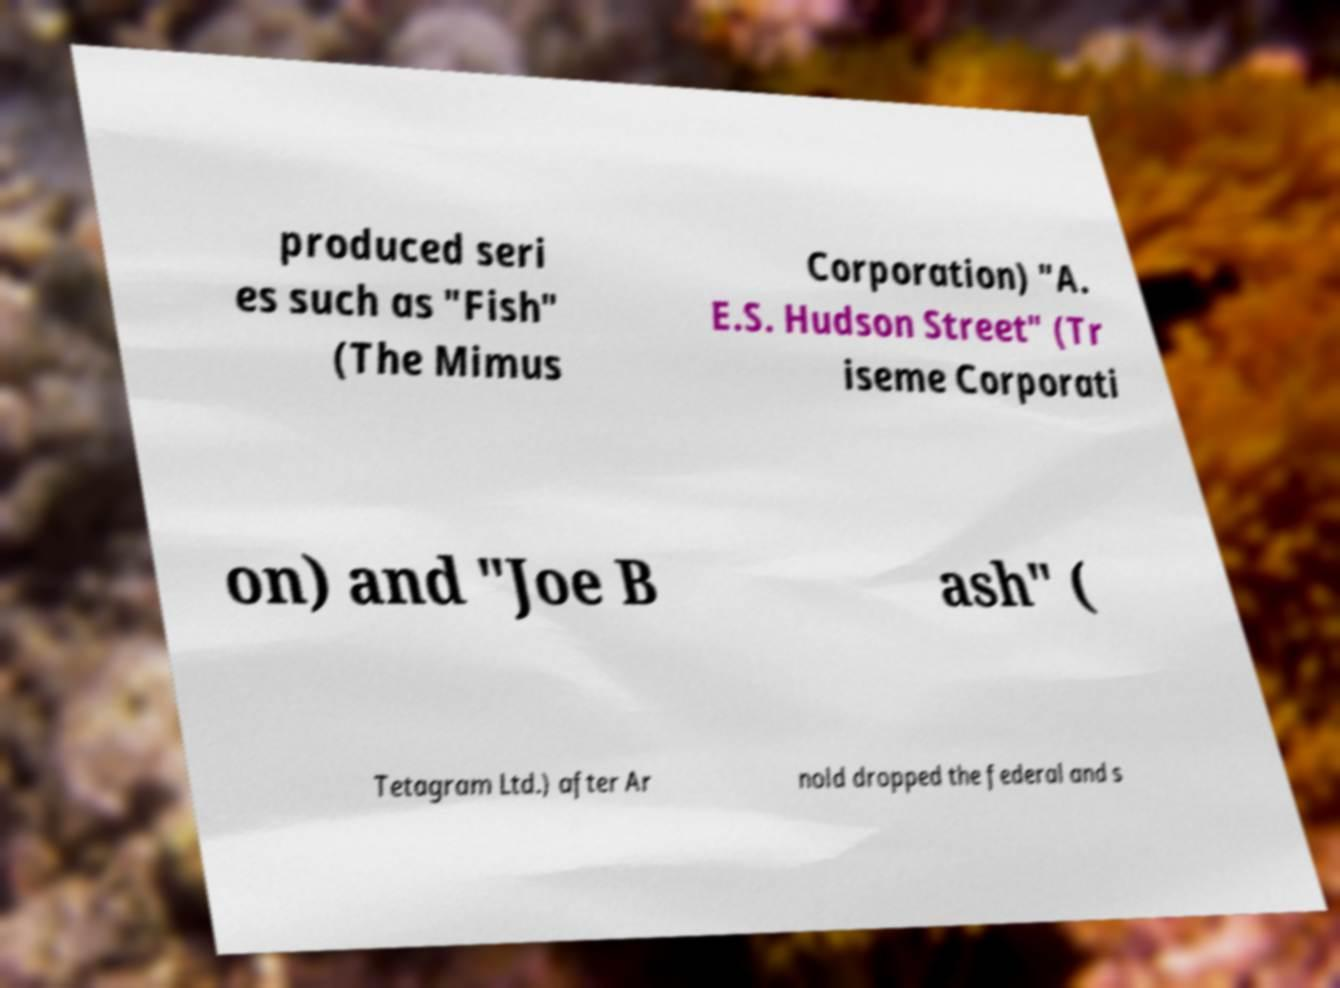Can you read and provide the text displayed in the image?This photo seems to have some interesting text. Can you extract and type it out for me? produced seri es such as "Fish" (The Mimus Corporation) "A. E.S. Hudson Street" (Tr iseme Corporati on) and "Joe B ash" ( Tetagram Ltd.) after Ar nold dropped the federal and s 